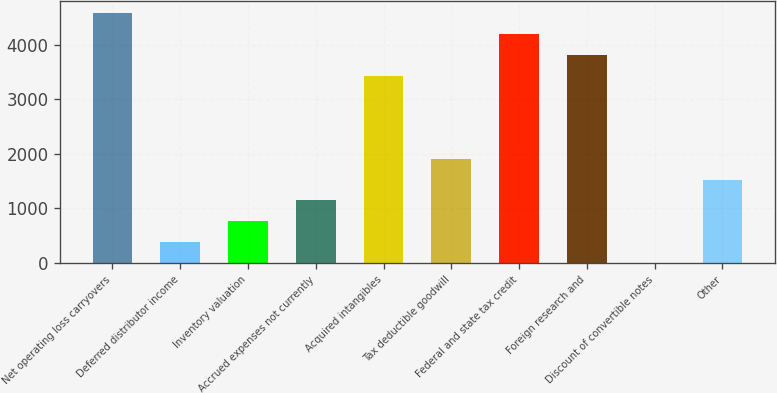Convert chart to OTSL. <chart><loc_0><loc_0><loc_500><loc_500><bar_chart><fcel>Net operating loss carryovers<fcel>Deferred distributor income<fcel>Inventory valuation<fcel>Accrued expenses not currently<fcel>Acquired intangibles<fcel>Tax deductible goodwill<fcel>Federal and state tax credit<fcel>Foreign research and<fcel>Discount of convertible notes<fcel>Other<nl><fcel>4570.4<fcel>382.7<fcel>763.4<fcel>1144.1<fcel>3428.3<fcel>1905.5<fcel>4189.7<fcel>3809<fcel>2<fcel>1524.8<nl></chart> 